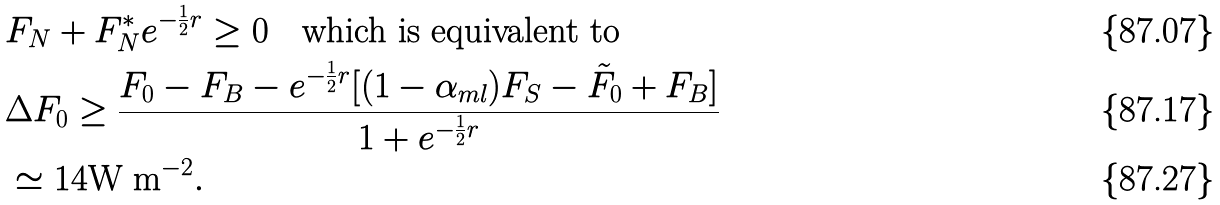<formula> <loc_0><loc_0><loc_500><loc_500>& F _ { N } + F ^ { \ast } _ { N } e ^ { - \frac { 1 } { 2 } r } \geq 0 \quad \text {which is equivalent to} \\ & \Delta F _ { 0 } \geq \frac { F _ { 0 } - F _ { B } - e ^ { - \frac { 1 } { 2 } r } [ ( 1 - \alpha _ { m l } ) F _ { S } - \tilde { F } _ { 0 } + F _ { B } ] } { 1 + e ^ { - \frac { 1 } { 2 } r } } \\ & \simeq 1 4 \text {W m} ^ { - 2 } .</formula> 